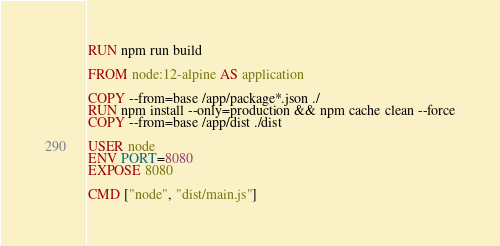<code> <loc_0><loc_0><loc_500><loc_500><_Dockerfile_>RUN npm run build

FROM node:12-alpine AS application

COPY --from=base /app/package*.json ./
RUN npm install --only=production && npm cache clean --force
COPY --from=base /app/dist ./dist

USER node
ENV PORT=8080
EXPOSE 8080

CMD ["node", "dist/main.js"]
</code> 